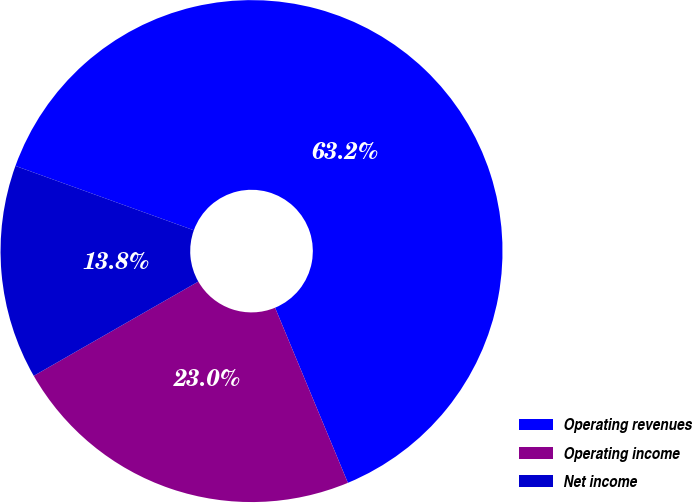Convert chart. <chart><loc_0><loc_0><loc_500><loc_500><pie_chart><fcel>Operating revenues<fcel>Operating income<fcel>Net income<nl><fcel>63.21%<fcel>22.99%<fcel>13.79%<nl></chart> 